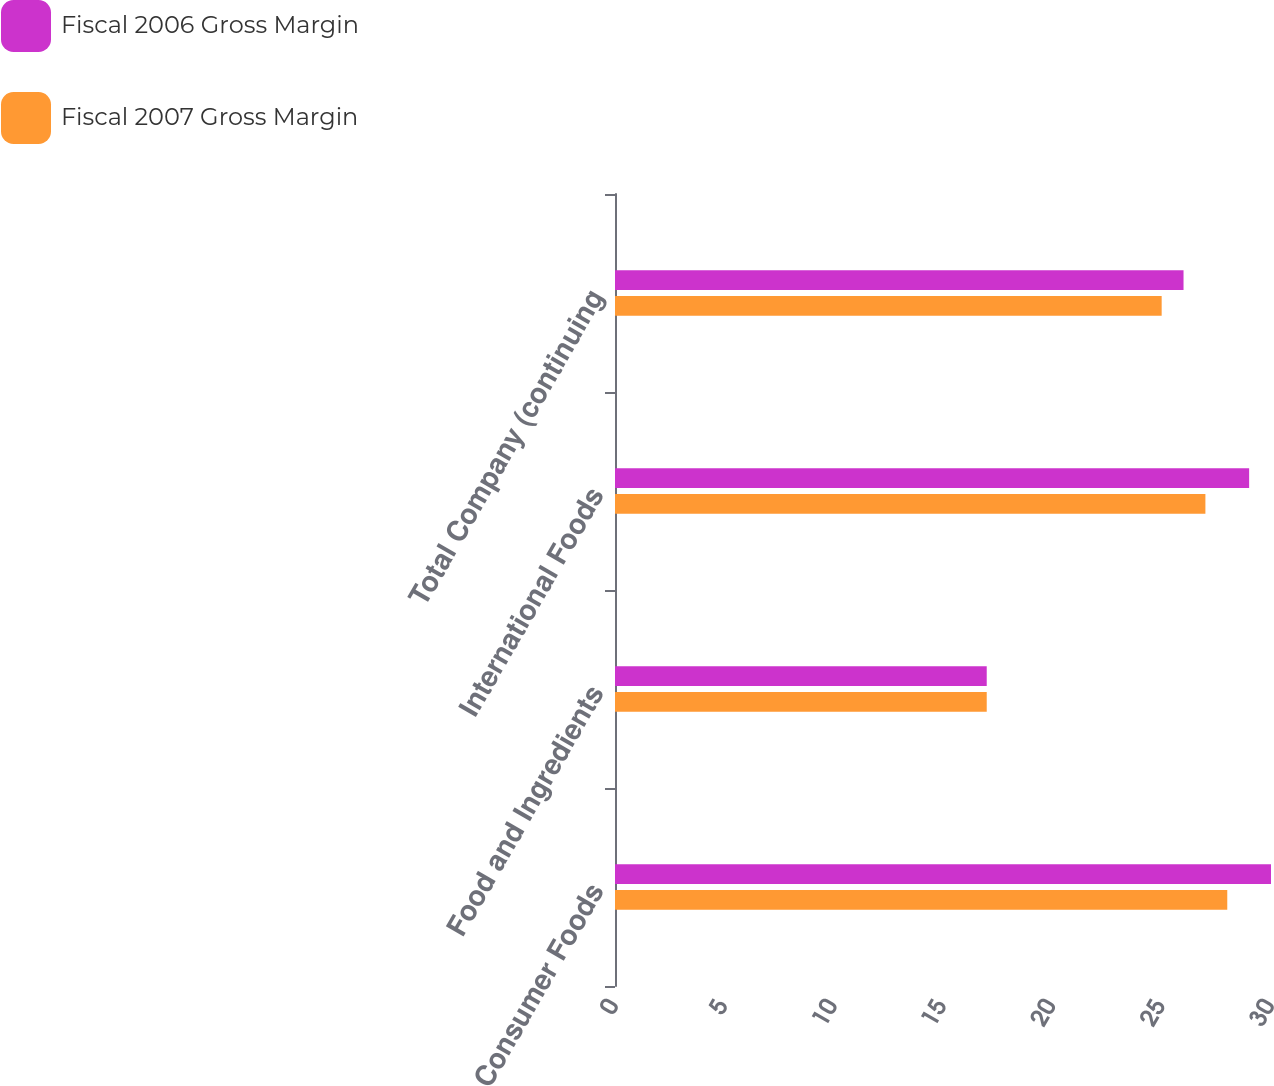Convert chart to OTSL. <chart><loc_0><loc_0><loc_500><loc_500><stacked_bar_chart><ecel><fcel>Consumer Foods<fcel>Food and Ingredients<fcel>International Foods<fcel>Total Company (continuing<nl><fcel>Fiscal 2006 Gross Margin<fcel>30<fcel>17<fcel>29<fcel>26<nl><fcel>Fiscal 2007 Gross Margin<fcel>28<fcel>17<fcel>27<fcel>25<nl></chart> 